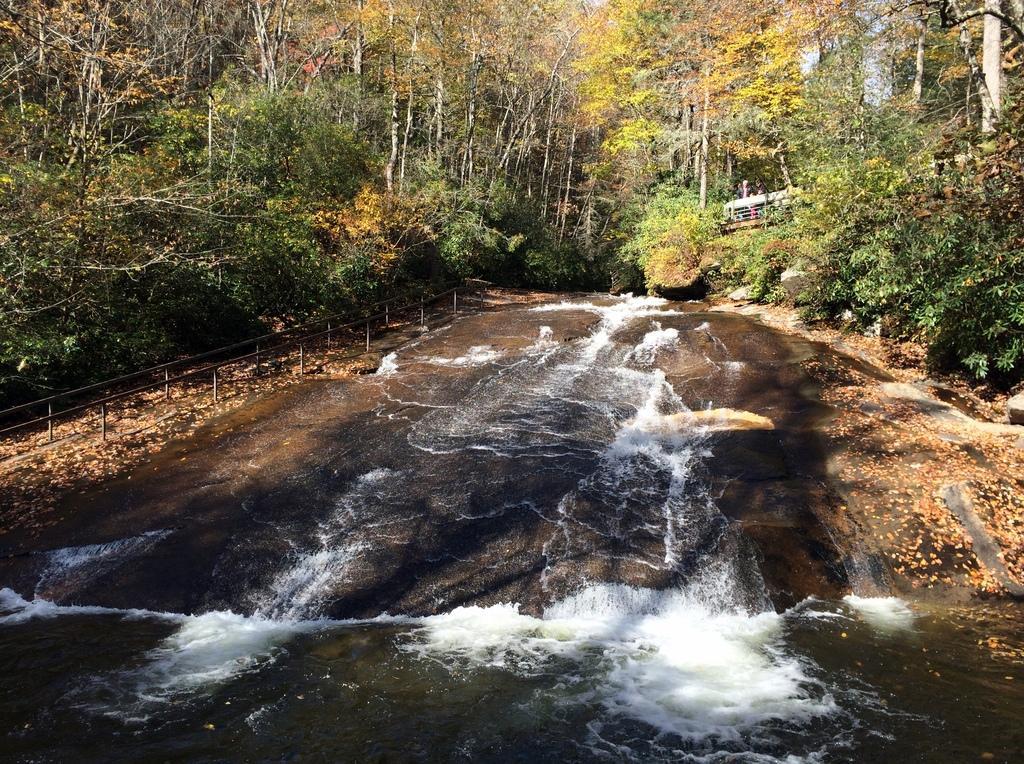Describe this image in one or two sentences. In this image there are trees, metal railing in the left and right corner. There is a water at the bottom. And there is a sky at the top. 